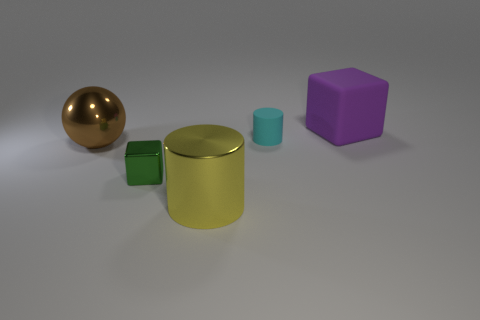Which objects appear to be the tallest and the shortest? In this image, the yellow cylinder seems to be the tallest object as it stands with a significant height relative to other objects. The shortest appears to be the small green cube, which has the least height amongst all the items present. 